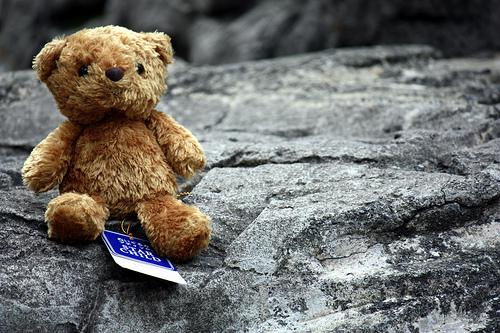Question: what is the bear on?
Choices:
A. Rocks.
B. Tree.
C. Grass.
D. Hill.
Answer with the letter. Answer: A Question: what color are the eyes?
Choices:
A. Black.
B. Red.
C. White.
D. Blue.
Answer with the letter. Answer: A Question: where is the shot?
Choices:
A. Rocks.
B. Tree.
C. Grass.
D. Mountain.
Answer with the letter. Answer: A Question: what texture is on the bear?
Choices:
A. Smooth.
B. Frizzy.
C. Fuzzy.
D. Bald.
Answer with the letter. Answer: C 